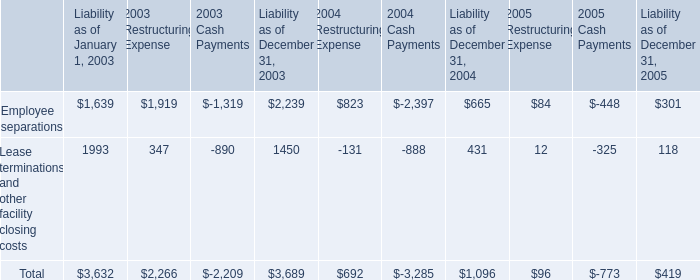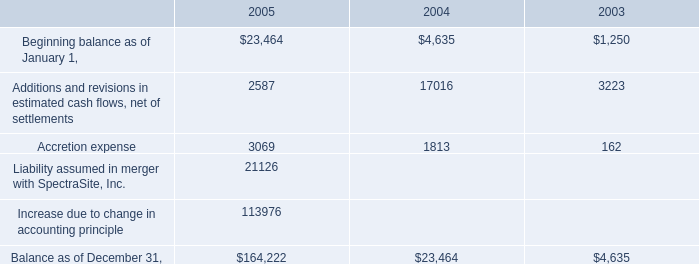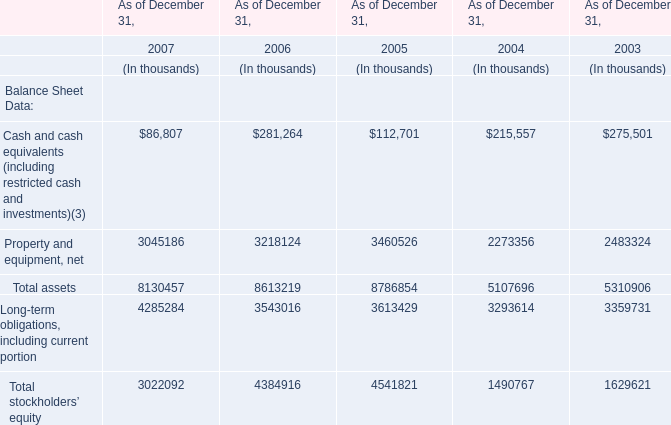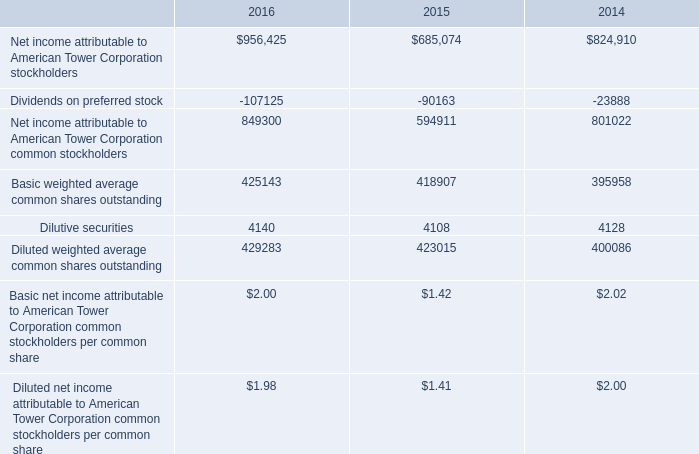What is the total amount of Liability assumed in merger with SpectraSite, Inc. of 2005, and Dividends on preferred stock of 2016 ? 
Computations: (21126.0 + 107125.0)
Answer: 128251.0. 